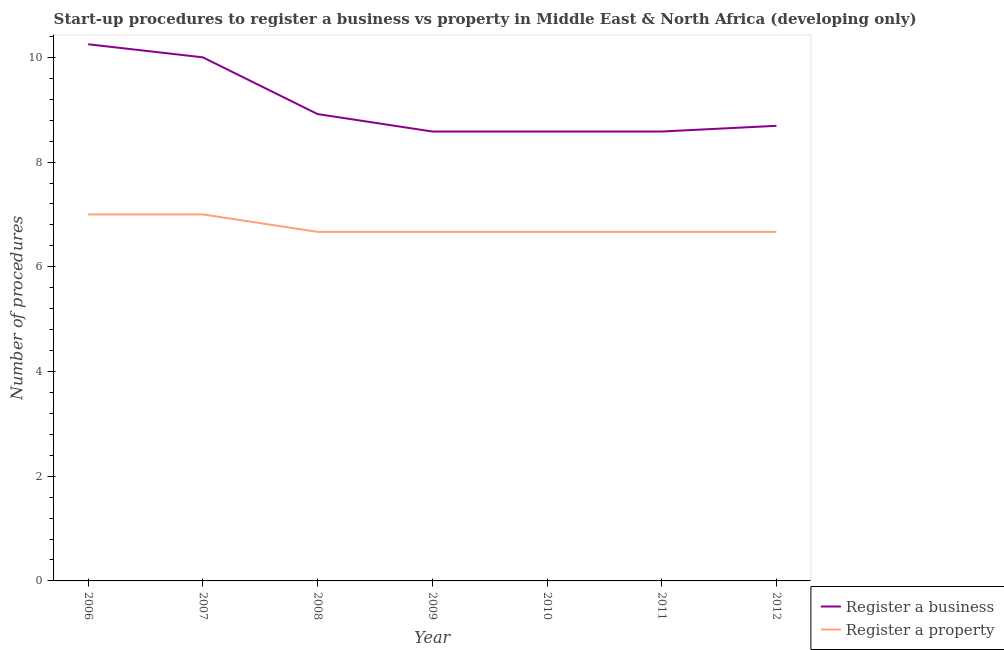What is the number of procedures to register a business in 2008?
Your response must be concise. 8.92. Across all years, what is the maximum number of procedures to register a business?
Ensure brevity in your answer.  10.25. Across all years, what is the minimum number of procedures to register a business?
Make the answer very short. 8.58. What is the total number of procedures to register a property in the graph?
Keep it short and to the point. 47.33. What is the difference between the number of procedures to register a property in 2006 and that in 2010?
Ensure brevity in your answer.  0.33. What is the difference between the number of procedures to register a business in 2012 and the number of procedures to register a property in 2010?
Give a very brief answer. 2.03. What is the average number of procedures to register a business per year?
Your answer should be compact. 9.09. In the year 2012, what is the difference between the number of procedures to register a business and number of procedures to register a property?
Make the answer very short. 2.03. In how many years, is the number of procedures to register a business greater than 4.4?
Your answer should be very brief. 7. What is the ratio of the number of procedures to register a property in 2006 to that in 2009?
Provide a succinct answer. 1.05. Is the difference between the number of procedures to register a property in 2006 and 2008 greater than the difference between the number of procedures to register a business in 2006 and 2008?
Your response must be concise. No. What is the difference between the highest and the second highest number of procedures to register a business?
Provide a short and direct response. 0.25. What is the difference between the highest and the lowest number of procedures to register a business?
Provide a short and direct response. 1.67. Is the sum of the number of procedures to register a business in 2009 and 2011 greater than the maximum number of procedures to register a property across all years?
Provide a short and direct response. Yes. Does the number of procedures to register a property monotonically increase over the years?
Your answer should be very brief. No. Is the number of procedures to register a property strictly greater than the number of procedures to register a business over the years?
Offer a very short reply. No. How many lines are there?
Your answer should be very brief. 2. What is the difference between two consecutive major ticks on the Y-axis?
Offer a terse response. 2. Are the values on the major ticks of Y-axis written in scientific E-notation?
Ensure brevity in your answer.  No. Does the graph contain grids?
Your response must be concise. No. What is the title of the graph?
Keep it short and to the point. Start-up procedures to register a business vs property in Middle East & North Africa (developing only). What is the label or title of the Y-axis?
Make the answer very short. Number of procedures. What is the Number of procedures of Register a business in 2006?
Your answer should be compact. 10.25. What is the Number of procedures of Register a business in 2007?
Offer a terse response. 10. What is the Number of procedures of Register a property in 2007?
Your response must be concise. 7. What is the Number of procedures of Register a business in 2008?
Keep it short and to the point. 8.92. What is the Number of procedures of Register a property in 2008?
Your response must be concise. 6.67. What is the Number of procedures in Register a business in 2009?
Give a very brief answer. 8.58. What is the Number of procedures of Register a property in 2009?
Make the answer very short. 6.67. What is the Number of procedures of Register a business in 2010?
Your answer should be compact. 8.58. What is the Number of procedures in Register a property in 2010?
Your response must be concise. 6.67. What is the Number of procedures in Register a business in 2011?
Keep it short and to the point. 8.58. What is the Number of procedures in Register a property in 2011?
Make the answer very short. 6.67. What is the Number of procedures of Register a business in 2012?
Make the answer very short. 8.69. What is the Number of procedures in Register a property in 2012?
Give a very brief answer. 6.67. Across all years, what is the maximum Number of procedures of Register a business?
Your answer should be compact. 10.25. Across all years, what is the minimum Number of procedures of Register a business?
Give a very brief answer. 8.58. Across all years, what is the minimum Number of procedures of Register a property?
Your answer should be very brief. 6.67. What is the total Number of procedures in Register a business in the graph?
Provide a succinct answer. 63.61. What is the total Number of procedures in Register a property in the graph?
Your answer should be very brief. 47.33. What is the difference between the Number of procedures in Register a business in 2006 and that in 2007?
Offer a very short reply. 0.25. What is the difference between the Number of procedures in Register a property in 2006 and that in 2007?
Give a very brief answer. 0. What is the difference between the Number of procedures of Register a property in 2006 and that in 2008?
Your response must be concise. 0.33. What is the difference between the Number of procedures in Register a property in 2006 and that in 2009?
Provide a succinct answer. 0.33. What is the difference between the Number of procedures of Register a business in 2006 and that in 2010?
Ensure brevity in your answer.  1.67. What is the difference between the Number of procedures of Register a property in 2006 and that in 2010?
Ensure brevity in your answer.  0.33. What is the difference between the Number of procedures in Register a business in 2006 and that in 2011?
Ensure brevity in your answer.  1.67. What is the difference between the Number of procedures of Register a business in 2006 and that in 2012?
Your answer should be compact. 1.56. What is the difference between the Number of procedures of Register a business in 2007 and that in 2008?
Offer a very short reply. 1.08. What is the difference between the Number of procedures of Register a property in 2007 and that in 2008?
Your answer should be compact. 0.33. What is the difference between the Number of procedures of Register a business in 2007 and that in 2009?
Make the answer very short. 1.42. What is the difference between the Number of procedures of Register a property in 2007 and that in 2009?
Keep it short and to the point. 0.33. What is the difference between the Number of procedures of Register a business in 2007 and that in 2010?
Your response must be concise. 1.42. What is the difference between the Number of procedures of Register a property in 2007 and that in 2010?
Your response must be concise. 0.33. What is the difference between the Number of procedures in Register a business in 2007 and that in 2011?
Make the answer very short. 1.42. What is the difference between the Number of procedures in Register a business in 2007 and that in 2012?
Offer a terse response. 1.31. What is the difference between the Number of procedures in Register a property in 2007 and that in 2012?
Make the answer very short. 0.33. What is the difference between the Number of procedures of Register a business in 2008 and that in 2009?
Your response must be concise. 0.33. What is the difference between the Number of procedures in Register a property in 2008 and that in 2009?
Offer a very short reply. 0. What is the difference between the Number of procedures of Register a business in 2008 and that in 2010?
Make the answer very short. 0.33. What is the difference between the Number of procedures in Register a business in 2008 and that in 2012?
Your response must be concise. 0.22. What is the difference between the Number of procedures in Register a property in 2008 and that in 2012?
Provide a succinct answer. 0. What is the difference between the Number of procedures of Register a business in 2009 and that in 2010?
Your response must be concise. 0. What is the difference between the Number of procedures in Register a property in 2009 and that in 2010?
Ensure brevity in your answer.  0. What is the difference between the Number of procedures in Register a property in 2009 and that in 2011?
Give a very brief answer. 0. What is the difference between the Number of procedures of Register a business in 2009 and that in 2012?
Your answer should be compact. -0.11. What is the difference between the Number of procedures in Register a business in 2010 and that in 2011?
Give a very brief answer. 0. What is the difference between the Number of procedures of Register a property in 2010 and that in 2011?
Your answer should be compact. 0. What is the difference between the Number of procedures in Register a business in 2010 and that in 2012?
Ensure brevity in your answer.  -0.11. What is the difference between the Number of procedures of Register a property in 2010 and that in 2012?
Ensure brevity in your answer.  0. What is the difference between the Number of procedures of Register a business in 2011 and that in 2012?
Give a very brief answer. -0.11. What is the difference between the Number of procedures of Register a property in 2011 and that in 2012?
Provide a short and direct response. 0. What is the difference between the Number of procedures in Register a business in 2006 and the Number of procedures in Register a property in 2007?
Offer a very short reply. 3.25. What is the difference between the Number of procedures of Register a business in 2006 and the Number of procedures of Register a property in 2008?
Keep it short and to the point. 3.58. What is the difference between the Number of procedures in Register a business in 2006 and the Number of procedures in Register a property in 2009?
Ensure brevity in your answer.  3.58. What is the difference between the Number of procedures in Register a business in 2006 and the Number of procedures in Register a property in 2010?
Ensure brevity in your answer.  3.58. What is the difference between the Number of procedures of Register a business in 2006 and the Number of procedures of Register a property in 2011?
Offer a terse response. 3.58. What is the difference between the Number of procedures in Register a business in 2006 and the Number of procedures in Register a property in 2012?
Provide a short and direct response. 3.58. What is the difference between the Number of procedures in Register a business in 2007 and the Number of procedures in Register a property in 2012?
Make the answer very short. 3.33. What is the difference between the Number of procedures in Register a business in 2008 and the Number of procedures in Register a property in 2009?
Your answer should be compact. 2.25. What is the difference between the Number of procedures in Register a business in 2008 and the Number of procedures in Register a property in 2010?
Your response must be concise. 2.25. What is the difference between the Number of procedures in Register a business in 2008 and the Number of procedures in Register a property in 2011?
Ensure brevity in your answer.  2.25. What is the difference between the Number of procedures of Register a business in 2008 and the Number of procedures of Register a property in 2012?
Keep it short and to the point. 2.25. What is the difference between the Number of procedures in Register a business in 2009 and the Number of procedures in Register a property in 2010?
Provide a short and direct response. 1.92. What is the difference between the Number of procedures in Register a business in 2009 and the Number of procedures in Register a property in 2011?
Make the answer very short. 1.92. What is the difference between the Number of procedures in Register a business in 2009 and the Number of procedures in Register a property in 2012?
Make the answer very short. 1.92. What is the difference between the Number of procedures of Register a business in 2010 and the Number of procedures of Register a property in 2011?
Provide a succinct answer. 1.92. What is the difference between the Number of procedures in Register a business in 2010 and the Number of procedures in Register a property in 2012?
Your answer should be very brief. 1.92. What is the difference between the Number of procedures in Register a business in 2011 and the Number of procedures in Register a property in 2012?
Your response must be concise. 1.92. What is the average Number of procedures of Register a business per year?
Keep it short and to the point. 9.09. What is the average Number of procedures of Register a property per year?
Provide a short and direct response. 6.76. In the year 2006, what is the difference between the Number of procedures of Register a business and Number of procedures of Register a property?
Ensure brevity in your answer.  3.25. In the year 2008, what is the difference between the Number of procedures in Register a business and Number of procedures in Register a property?
Keep it short and to the point. 2.25. In the year 2009, what is the difference between the Number of procedures of Register a business and Number of procedures of Register a property?
Your answer should be compact. 1.92. In the year 2010, what is the difference between the Number of procedures of Register a business and Number of procedures of Register a property?
Provide a short and direct response. 1.92. In the year 2011, what is the difference between the Number of procedures in Register a business and Number of procedures in Register a property?
Provide a succinct answer. 1.92. In the year 2012, what is the difference between the Number of procedures in Register a business and Number of procedures in Register a property?
Give a very brief answer. 2.03. What is the ratio of the Number of procedures in Register a business in 2006 to that in 2007?
Your answer should be very brief. 1.02. What is the ratio of the Number of procedures in Register a property in 2006 to that in 2007?
Provide a succinct answer. 1. What is the ratio of the Number of procedures in Register a business in 2006 to that in 2008?
Give a very brief answer. 1.15. What is the ratio of the Number of procedures in Register a property in 2006 to that in 2008?
Your response must be concise. 1.05. What is the ratio of the Number of procedures of Register a business in 2006 to that in 2009?
Provide a succinct answer. 1.19. What is the ratio of the Number of procedures in Register a property in 2006 to that in 2009?
Give a very brief answer. 1.05. What is the ratio of the Number of procedures in Register a business in 2006 to that in 2010?
Offer a very short reply. 1.19. What is the ratio of the Number of procedures of Register a business in 2006 to that in 2011?
Offer a very short reply. 1.19. What is the ratio of the Number of procedures in Register a property in 2006 to that in 2011?
Ensure brevity in your answer.  1.05. What is the ratio of the Number of procedures in Register a business in 2006 to that in 2012?
Offer a very short reply. 1.18. What is the ratio of the Number of procedures of Register a business in 2007 to that in 2008?
Ensure brevity in your answer.  1.12. What is the ratio of the Number of procedures of Register a business in 2007 to that in 2009?
Your answer should be very brief. 1.17. What is the ratio of the Number of procedures of Register a business in 2007 to that in 2010?
Your answer should be very brief. 1.17. What is the ratio of the Number of procedures in Register a property in 2007 to that in 2010?
Make the answer very short. 1.05. What is the ratio of the Number of procedures of Register a business in 2007 to that in 2011?
Offer a very short reply. 1.17. What is the ratio of the Number of procedures of Register a property in 2007 to that in 2011?
Keep it short and to the point. 1.05. What is the ratio of the Number of procedures of Register a business in 2007 to that in 2012?
Make the answer very short. 1.15. What is the ratio of the Number of procedures of Register a business in 2008 to that in 2009?
Give a very brief answer. 1.04. What is the ratio of the Number of procedures of Register a property in 2008 to that in 2009?
Provide a succinct answer. 1. What is the ratio of the Number of procedures in Register a business in 2008 to that in 2010?
Keep it short and to the point. 1.04. What is the ratio of the Number of procedures in Register a business in 2008 to that in 2011?
Give a very brief answer. 1.04. What is the ratio of the Number of procedures of Register a property in 2008 to that in 2011?
Keep it short and to the point. 1. What is the ratio of the Number of procedures of Register a business in 2008 to that in 2012?
Offer a very short reply. 1.03. What is the ratio of the Number of procedures of Register a business in 2009 to that in 2011?
Give a very brief answer. 1. What is the ratio of the Number of procedures of Register a business in 2009 to that in 2012?
Provide a short and direct response. 0.99. What is the ratio of the Number of procedures in Register a business in 2010 to that in 2012?
Your answer should be compact. 0.99. What is the ratio of the Number of procedures in Register a business in 2011 to that in 2012?
Provide a succinct answer. 0.99. What is the ratio of the Number of procedures in Register a property in 2011 to that in 2012?
Ensure brevity in your answer.  1. What is the difference between the highest and the second highest Number of procedures of Register a business?
Offer a very short reply. 0.25. What is the difference between the highest and the lowest Number of procedures of Register a business?
Offer a very short reply. 1.67. 